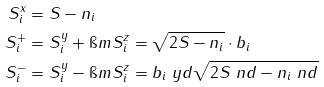<formula> <loc_0><loc_0><loc_500><loc_500>S ^ { x } _ { i } & = S - n _ { i } \\ S ^ { + } _ { i } & = S ^ { y } _ { i } + \i m S ^ { z } _ { i } = \sqrt { 2 S - n _ { i } } \cdot b _ { i } \\ S ^ { - } _ { i } & = S ^ { y } _ { i } - \i m S ^ { z } _ { i } = b _ { i } \ y d \sqrt { 2 S \ n d - n _ { i } \ n d }</formula> 